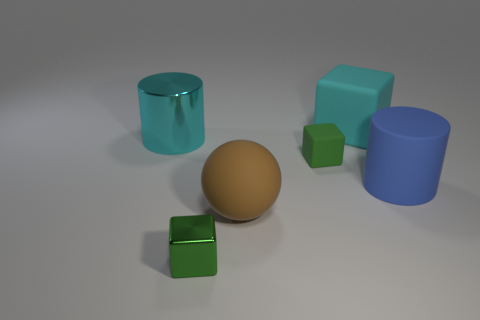How big is the blue cylinder?
Offer a very short reply. Large. How many cylinders are the same size as the shiny cube?
Your response must be concise. 0. How many rubber objects are the same shape as the tiny metal object?
Provide a short and direct response. 2. Are there an equal number of cyan matte blocks that are to the left of the tiny metal object and large red metallic balls?
Provide a succinct answer. Yes. Is there any other thing that is the same size as the metal cube?
Provide a succinct answer. Yes. What shape is the cyan rubber object that is the same size as the brown object?
Your answer should be very brief. Cube. Is there a blue object that has the same shape as the small green metal object?
Ensure brevity in your answer.  No. There is a tiny green block that is behind the block that is on the left side of the brown rubber thing; are there any rubber cubes that are behind it?
Your response must be concise. Yes. Is the number of tiny cubes in front of the small shiny cube greater than the number of green matte cubes that are behind the shiny cylinder?
Your answer should be compact. No. There is a cyan cube that is the same size as the ball; what is its material?
Make the answer very short. Rubber. 